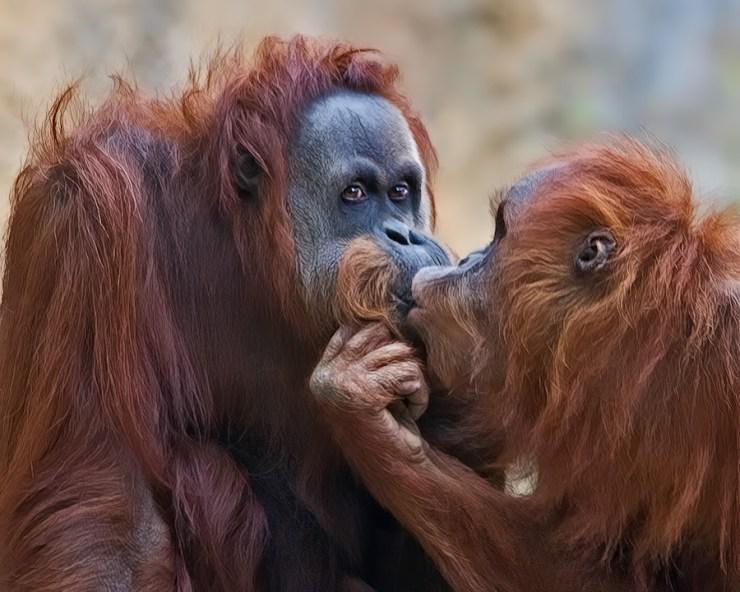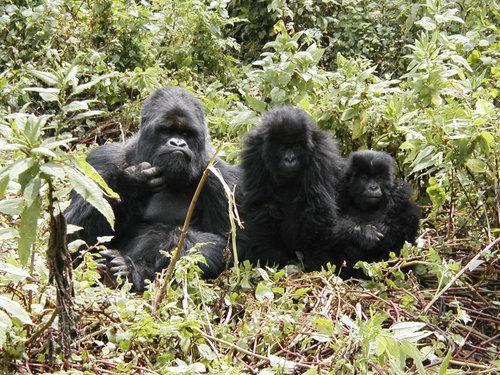The first image is the image on the left, the second image is the image on the right. Considering the images on both sides, is "At least one primate is looking directly forward." valid? Answer yes or no. Yes. The first image is the image on the left, the second image is the image on the right. Assess this claim about the two images: "One gorilla is scratching its own chin.". Correct or not? Answer yes or no. Yes. 